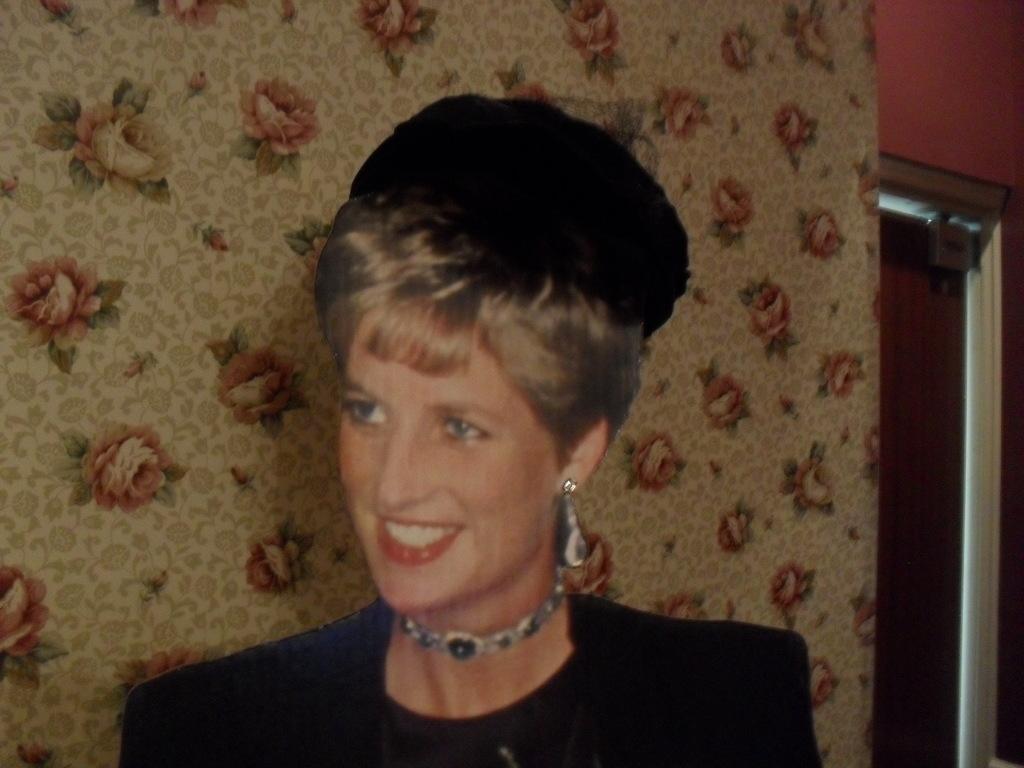Please provide a concise description of this image. There is a woman in the given picture having a smile on her face. She is wearing a black dress and a necklace around her neck. She is wearing an earring. In the background we can observe a curtain here. In the top right corner, we can observe an entrance and a wall there. 